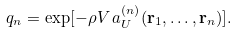<formula> <loc_0><loc_0><loc_500><loc_500>q _ { n } = \exp [ - \rho V \, a ^ { ( n ) } _ { U } ( { \mathbf r } _ { 1 } , \dots , { \mathbf r } _ { n } ) ] .</formula> 